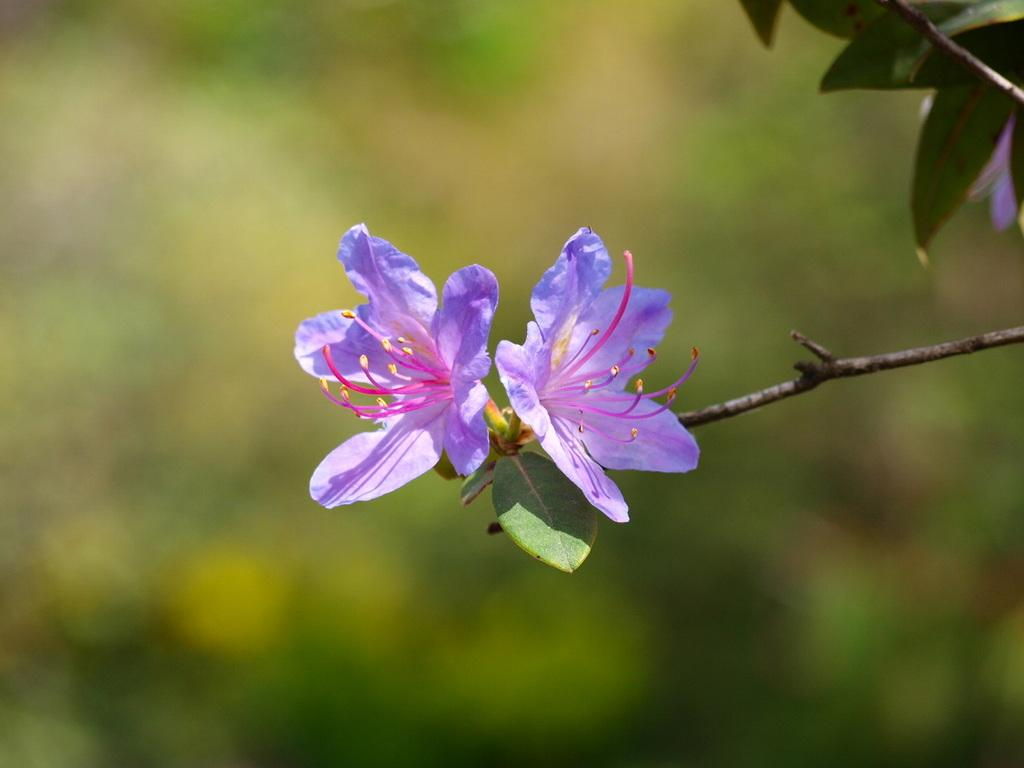What type of plants can be seen in the image? There are flowers in the image. Can you describe the flowers' stems? The stems of the flowers in the image have leaves on them. What type of brush can be seen in the image? There is no brush present in the image; it features flowers with leaves on their stems. 